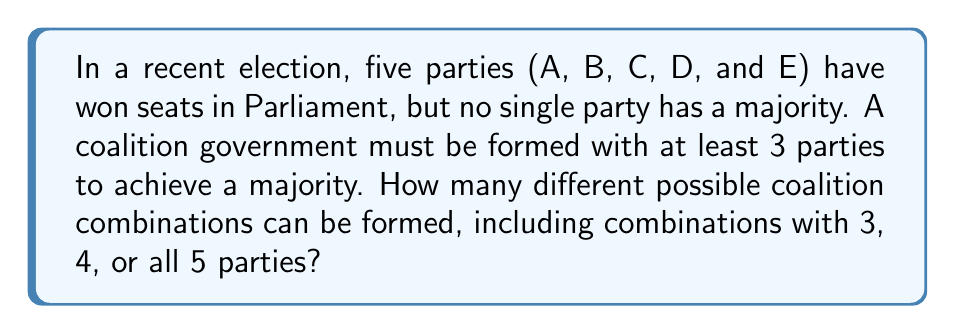Can you answer this question? To solve this problem, we need to use the concept of combinations. We'll break it down step-by-step:

1. First, let's calculate the number of possible 3-party coalitions:
   We need to choose 3 parties out of 5, which is denoted as $\binom{5}{3}$.
   $$\binom{5}{3} = \frac{5!}{3!(5-3)!} = \frac{5 \cdot 4 \cdot 3}{3 \cdot 2 \cdot 1} = 10$$

2. Next, let's calculate the number of possible 4-party coalitions:
   We need to choose 4 parties out of 5, which is $\binom{5}{4}$.
   $$\binom{5}{4} = \frac{5!}{4!(5-4)!} = \frac{5}{1} = 5$$

3. Finally, there's only one way to form a coalition with all 5 parties:
   $\binom{5}{5} = 1$

4. To get the total number of possible coalitions, we sum up all these combinations:
   $$\text{Total combinations} = \binom{5}{3} + \binom{5}{4} + \binom{5}{5} = 10 + 5 + 1 = 16$$

Therefore, there are 16 different possible coalition combinations that can be formed.
Answer: 16 possible coalition combinations 